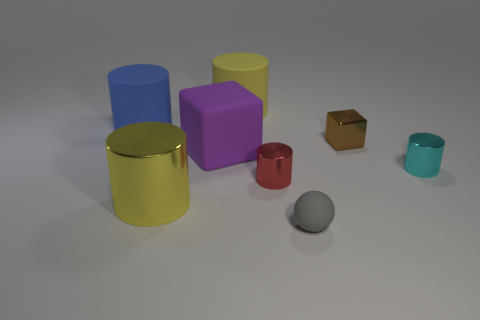The cyan metallic object is what shape?
Keep it short and to the point. Cylinder. What number of metallic things have the same size as the brown block?
Your answer should be very brief. 2. Is the shape of the tiny red metal object the same as the big yellow rubber thing?
Your answer should be compact. Yes. What color is the tiny cylinder on the left side of the tiny thing that is in front of the big metallic thing?
Make the answer very short. Red. There is a object that is in front of the brown thing and to the right of the small matte sphere; what size is it?
Your answer should be very brief. Small. Are there any other things that have the same color as the small ball?
Make the answer very short. No. The yellow thing that is made of the same material as the gray ball is what shape?
Your response must be concise. Cylinder. There is a blue object; is it the same shape as the big yellow thing left of the big purple thing?
Your answer should be very brief. Yes. The yellow cylinder behind the tiny object that is behind the cyan thing is made of what material?
Provide a short and direct response. Rubber. Is the number of yellow shiny things to the right of the big yellow metal object the same as the number of large purple rubber blocks?
Your response must be concise. No. 